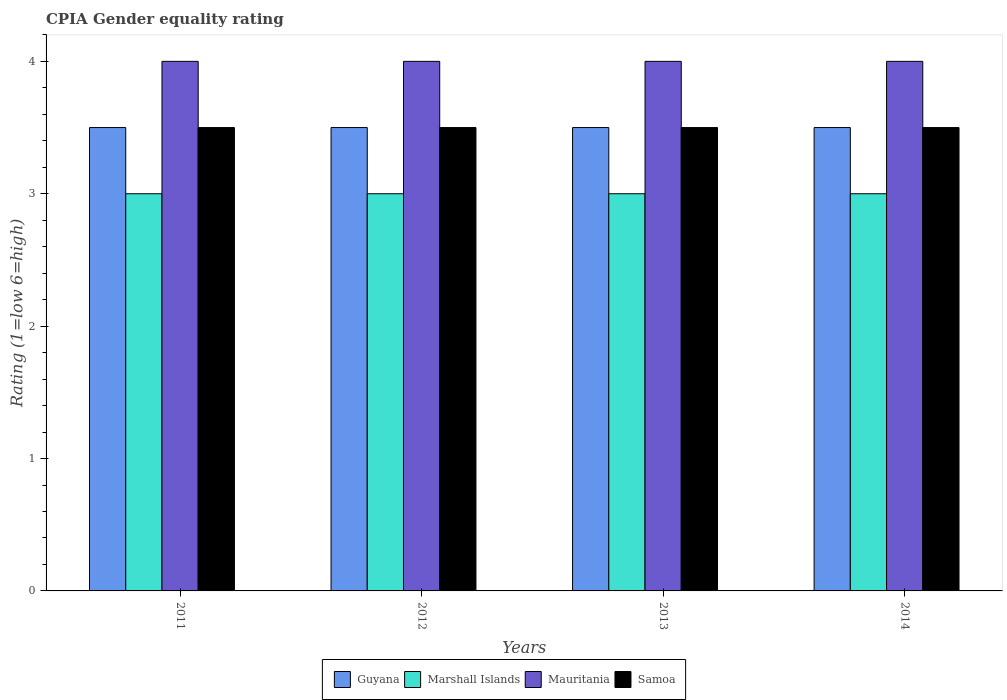How many different coloured bars are there?
Keep it short and to the point. 4. How many bars are there on the 3rd tick from the left?
Your answer should be very brief. 4. How many bars are there on the 2nd tick from the right?
Offer a terse response. 4. What is the CPIA rating in Samoa in 2011?
Make the answer very short. 3.5. Across all years, what is the minimum CPIA rating in Samoa?
Your response must be concise. 3.5. What is the total CPIA rating in Mauritania in the graph?
Offer a very short reply. 16. What is the difference between the CPIA rating in Samoa in 2011 and that in 2013?
Offer a terse response. 0. What is the ratio of the CPIA rating in Marshall Islands in 2011 to that in 2013?
Keep it short and to the point. 1. Is the CPIA rating in Samoa in 2012 less than that in 2014?
Provide a succinct answer. No. What is the difference between the highest and the second highest CPIA rating in Marshall Islands?
Offer a terse response. 0. What is the difference between the highest and the lowest CPIA rating in Marshall Islands?
Your answer should be very brief. 0. What does the 3rd bar from the left in 2011 represents?
Provide a short and direct response. Mauritania. What does the 3rd bar from the right in 2014 represents?
Your response must be concise. Marshall Islands. How many years are there in the graph?
Your answer should be compact. 4. Are the values on the major ticks of Y-axis written in scientific E-notation?
Ensure brevity in your answer.  No. Does the graph contain any zero values?
Provide a succinct answer. No. Does the graph contain grids?
Your response must be concise. No. How many legend labels are there?
Ensure brevity in your answer.  4. What is the title of the graph?
Your answer should be very brief. CPIA Gender equality rating. What is the label or title of the Y-axis?
Make the answer very short. Rating (1=low 6=high). What is the Rating (1=low 6=high) of Marshall Islands in 2011?
Keep it short and to the point. 3. What is the Rating (1=low 6=high) in Mauritania in 2011?
Give a very brief answer. 4. What is the Rating (1=low 6=high) in Marshall Islands in 2012?
Offer a very short reply. 3. What is the Rating (1=low 6=high) of Mauritania in 2012?
Offer a very short reply. 4. What is the Rating (1=low 6=high) in Samoa in 2012?
Offer a very short reply. 3.5. What is the Rating (1=low 6=high) in Marshall Islands in 2013?
Ensure brevity in your answer.  3. What is the Rating (1=low 6=high) in Samoa in 2013?
Your answer should be very brief. 3.5. What is the Rating (1=low 6=high) of Marshall Islands in 2014?
Give a very brief answer. 3. What is the Rating (1=low 6=high) of Samoa in 2014?
Your response must be concise. 3.5. Across all years, what is the maximum Rating (1=low 6=high) in Mauritania?
Ensure brevity in your answer.  4. Across all years, what is the maximum Rating (1=low 6=high) of Samoa?
Offer a terse response. 3.5. Across all years, what is the minimum Rating (1=low 6=high) in Marshall Islands?
Your answer should be very brief. 3. Across all years, what is the minimum Rating (1=low 6=high) of Mauritania?
Make the answer very short. 4. What is the total Rating (1=low 6=high) of Marshall Islands in the graph?
Offer a terse response. 12. What is the total Rating (1=low 6=high) in Mauritania in the graph?
Ensure brevity in your answer.  16. What is the difference between the Rating (1=low 6=high) in Guyana in 2011 and that in 2012?
Your answer should be compact. 0. What is the difference between the Rating (1=low 6=high) of Marshall Islands in 2011 and that in 2012?
Provide a short and direct response. 0. What is the difference between the Rating (1=low 6=high) of Mauritania in 2011 and that in 2012?
Give a very brief answer. 0. What is the difference between the Rating (1=low 6=high) in Samoa in 2011 and that in 2012?
Your answer should be very brief. 0. What is the difference between the Rating (1=low 6=high) of Guyana in 2011 and that in 2013?
Your response must be concise. 0. What is the difference between the Rating (1=low 6=high) of Mauritania in 2011 and that in 2013?
Give a very brief answer. 0. What is the difference between the Rating (1=low 6=high) in Marshall Islands in 2011 and that in 2014?
Give a very brief answer. 0. What is the difference between the Rating (1=low 6=high) of Samoa in 2011 and that in 2014?
Your answer should be very brief. 0. What is the difference between the Rating (1=low 6=high) in Marshall Islands in 2012 and that in 2013?
Your answer should be compact. 0. What is the difference between the Rating (1=low 6=high) of Samoa in 2012 and that in 2013?
Offer a very short reply. 0. What is the difference between the Rating (1=low 6=high) of Guyana in 2012 and that in 2014?
Provide a succinct answer. 0. What is the difference between the Rating (1=low 6=high) in Mauritania in 2012 and that in 2014?
Your answer should be compact. 0. What is the difference between the Rating (1=low 6=high) of Samoa in 2012 and that in 2014?
Offer a very short reply. 0. What is the difference between the Rating (1=low 6=high) of Marshall Islands in 2013 and that in 2014?
Your answer should be compact. 0. What is the difference between the Rating (1=low 6=high) in Samoa in 2013 and that in 2014?
Offer a terse response. 0. What is the difference between the Rating (1=low 6=high) in Mauritania in 2011 and the Rating (1=low 6=high) in Samoa in 2012?
Offer a very short reply. 0.5. What is the difference between the Rating (1=low 6=high) of Guyana in 2011 and the Rating (1=low 6=high) of Marshall Islands in 2013?
Give a very brief answer. 0.5. What is the difference between the Rating (1=low 6=high) of Guyana in 2011 and the Rating (1=low 6=high) of Mauritania in 2013?
Ensure brevity in your answer.  -0.5. What is the difference between the Rating (1=low 6=high) of Marshall Islands in 2011 and the Rating (1=low 6=high) of Mauritania in 2013?
Give a very brief answer. -1. What is the difference between the Rating (1=low 6=high) of Guyana in 2011 and the Rating (1=low 6=high) of Mauritania in 2014?
Your answer should be very brief. -0.5. What is the difference between the Rating (1=low 6=high) in Guyana in 2011 and the Rating (1=low 6=high) in Samoa in 2014?
Your response must be concise. 0. What is the difference between the Rating (1=low 6=high) of Marshall Islands in 2011 and the Rating (1=low 6=high) of Mauritania in 2014?
Your answer should be very brief. -1. What is the difference between the Rating (1=low 6=high) in Marshall Islands in 2011 and the Rating (1=low 6=high) in Samoa in 2014?
Provide a short and direct response. -0.5. What is the difference between the Rating (1=low 6=high) in Guyana in 2012 and the Rating (1=low 6=high) in Marshall Islands in 2013?
Your answer should be compact. 0.5. What is the difference between the Rating (1=low 6=high) of Guyana in 2012 and the Rating (1=low 6=high) of Mauritania in 2013?
Make the answer very short. -0.5. What is the difference between the Rating (1=low 6=high) in Guyana in 2012 and the Rating (1=low 6=high) in Samoa in 2013?
Ensure brevity in your answer.  0. What is the difference between the Rating (1=low 6=high) of Marshall Islands in 2012 and the Rating (1=low 6=high) of Samoa in 2013?
Your answer should be very brief. -0.5. What is the difference between the Rating (1=low 6=high) of Mauritania in 2012 and the Rating (1=low 6=high) of Samoa in 2013?
Make the answer very short. 0.5. What is the difference between the Rating (1=low 6=high) in Guyana in 2012 and the Rating (1=low 6=high) in Marshall Islands in 2014?
Offer a very short reply. 0.5. What is the difference between the Rating (1=low 6=high) in Guyana in 2012 and the Rating (1=low 6=high) in Mauritania in 2014?
Your answer should be very brief. -0.5. What is the difference between the Rating (1=low 6=high) of Guyana in 2012 and the Rating (1=low 6=high) of Samoa in 2014?
Offer a very short reply. 0. What is the difference between the Rating (1=low 6=high) in Guyana in 2013 and the Rating (1=low 6=high) in Mauritania in 2014?
Your response must be concise. -0.5. What is the difference between the Rating (1=low 6=high) of Marshall Islands in 2013 and the Rating (1=low 6=high) of Mauritania in 2014?
Ensure brevity in your answer.  -1. What is the difference between the Rating (1=low 6=high) in Marshall Islands in 2013 and the Rating (1=low 6=high) in Samoa in 2014?
Your response must be concise. -0.5. What is the average Rating (1=low 6=high) in Mauritania per year?
Your response must be concise. 4. In the year 2011, what is the difference between the Rating (1=low 6=high) of Guyana and Rating (1=low 6=high) of Mauritania?
Provide a short and direct response. -0.5. In the year 2011, what is the difference between the Rating (1=low 6=high) of Guyana and Rating (1=low 6=high) of Samoa?
Offer a very short reply. 0. In the year 2011, what is the difference between the Rating (1=low 6=high) in Marshall Islands and Rating (1=low 6=high) in Mauritania?
Ensure brevity in your answer.  -1. In the year 2011, what is the difference between the Rating (1=low 6=high) of Marshall Islands and Rating (1=low 6=high) of Samoa?
Ensure brevity in your answer.  -0.5. In the year 2012, what is the difference between the Rating (1=low 6=high) in Guyana and Rating (1=low 6=high) in Mauritania?
Ensure brevity in your answer.  -0.5. In the year 2012, what is the difference between the Rating (1=low 6=high) of Marshall Islands and Rating (1=low 6=high) of Mauritania?
Give a very brief answer. -1. In the year 2012, what is the difference between the Rating (1=low 6=high) of Mauritania and Rating (1=low 6=high) of Samoa?
Your response must be concise. 0.5. In the year 2013, what is the difference between the Rating (1=low 6=high) of Mauritania and Rating (1=low 6=high) of Samoa?
Your response must be concise. 0.5. In the year 2014, what is the difference between the Rating (1=low 6=high) in Guyana and Rating (1=low 6=high) in Mauritania?
Provide a short and direct response. -0.5. In the year 2014, what is the difference between the Rating (1=low 6=high) in Guyana and Rating (1=low 6=high) in Samoa?
Keep it short and to the point. 0. In the year 2014, what is the difference between the Rating (1=low 6=high) in Marshall Islands and Rating (1=low 6=high) in Mauritania?
Your answer should be compact. -1. In the year 2014, what is the difference between the Rating (1=low 6=high) of Mauritania and Rating (1=low 6=high) of Samoa?
Keep it short and to the point. 0.5. What is the ratio of the Rating (1=low 6=high) of Marshall Islands in 2011 to that in 2012?
Ensure brevity in your answer.  1. What is the ratio of the Rating (1=low 6=high) of Marshall Islands in 2011 to that in 2013?
Offer a terse response. 1. What is the ratio of the Rating (1=low 6=high) in Mauritania in 2011 to that in 2013?
Offer a terse response. 1. What is the ratio of the Rating (1=low 6=high) in Guyana in 2011 to that in 2014?
Provide a succinct answer. 1. What is the ratio of the Rating (1=low 6=high) in Mauritania in 2011 to that in 2014?
Provide a succinct answer. 1. What is the ratio of the Rating (1=low 6=high) of Guyana in 2012 to that in 2014?
Provide a short and direct response. 1. What is the ratio of the Rating (1=low 6=high) in Mauritania in 2012 to that in 2014?
Provide a short and direct response. 1. What is the ratio of the Rating (1=low 6=high) in Samoa in 2012 to that in 2014?
Keep it short and to the point. 1. What is the ratio of the Rating (1=low 6=high) in Samoa in 2013 to that in 2014?
Your response must be concise. 1. What is the difference between the highest and the second highest Rating (1=low 6=high) in Guyana?
Offer a very short reply. 0. What is the difference between the highest and the second highest Rating (1=low 6=high) in Samoa?
Your response must be concise. 0. What is the difference between the highest and the lowest Rating (1=low 6=high) in Guyana?
Make the answer very short. 0. What is the difference between the highest and the lowest Rating (1=low 6=high) in Marshall Islands?
Offer a very short reply. 0. 